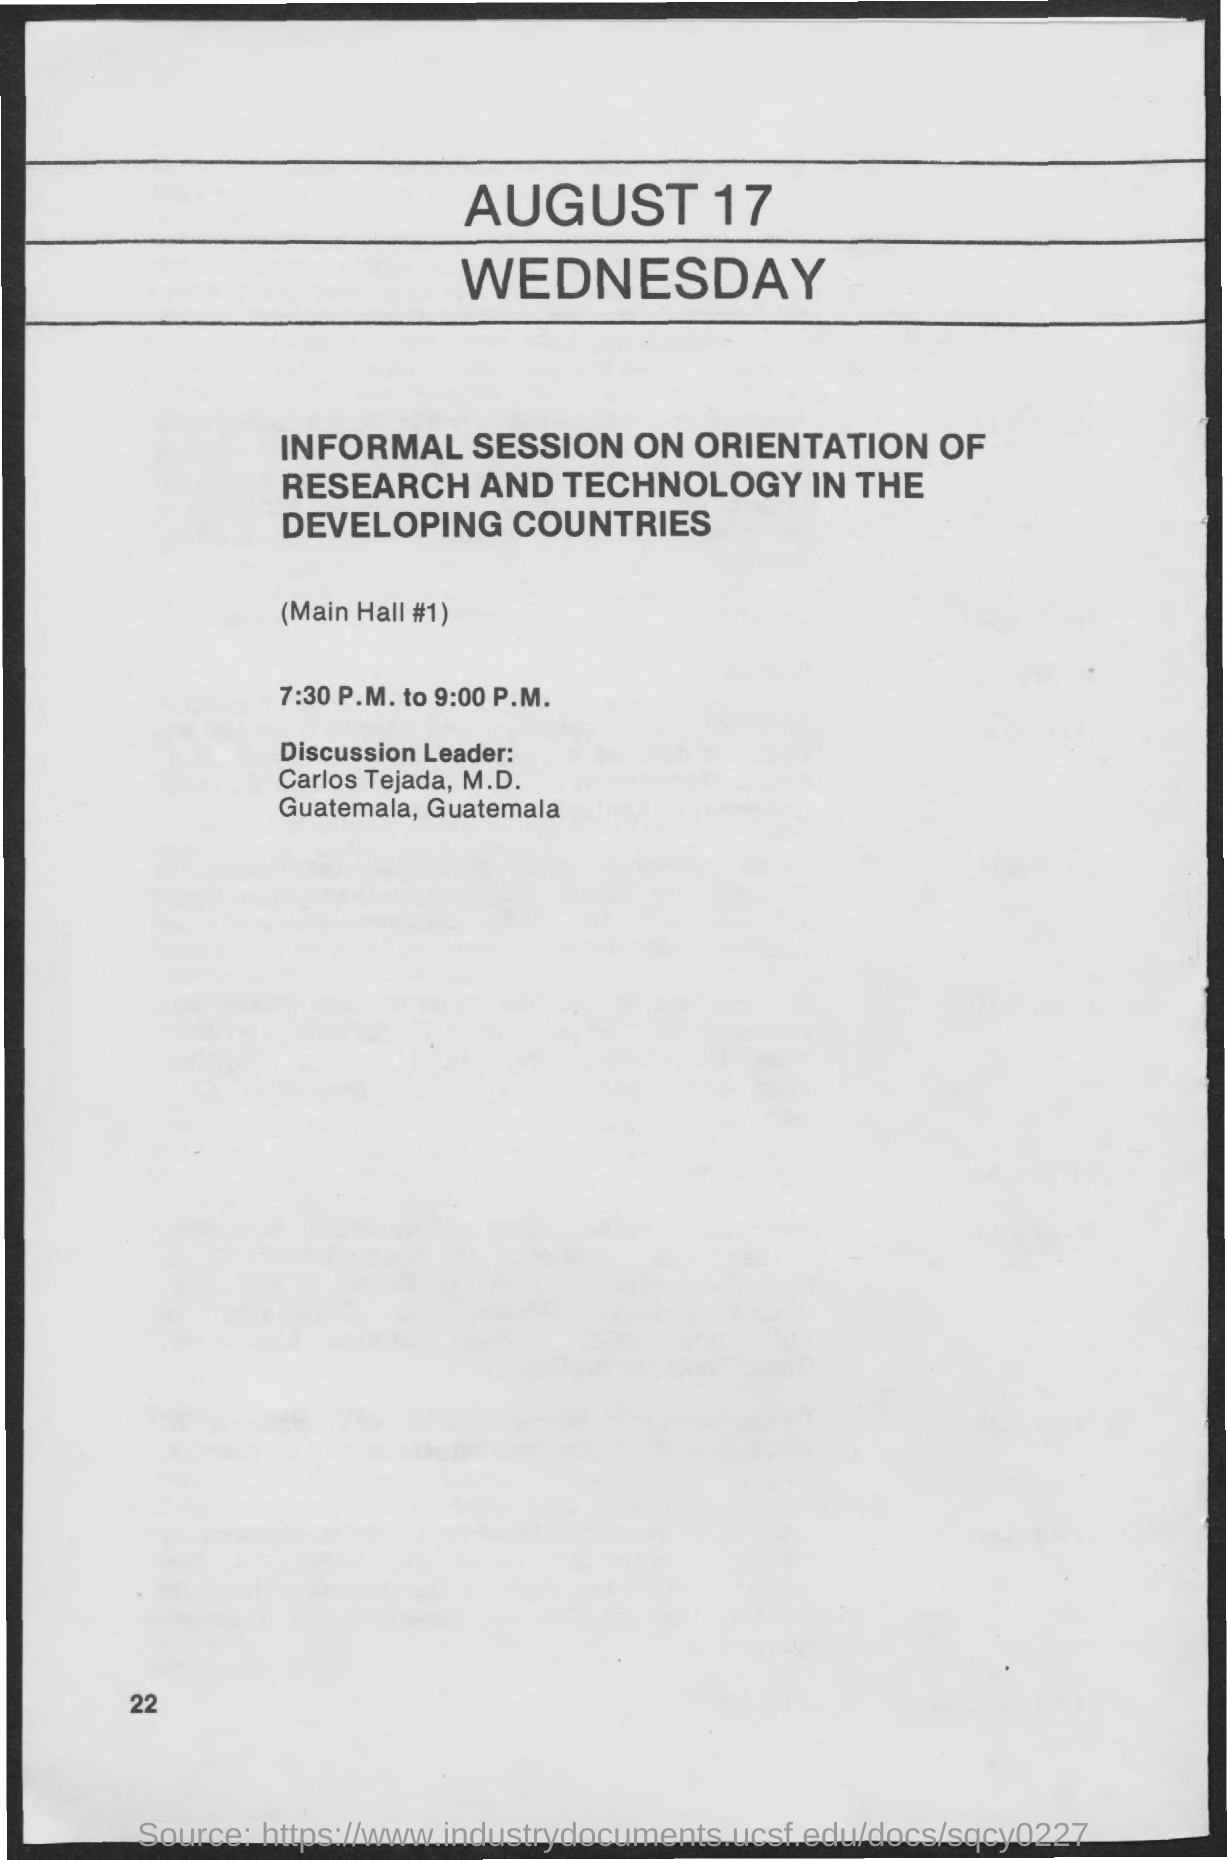Mention a couple of crucial points in this snapshot. The date on the document is August 17th. The informal session will take place from 7:30 P.M. to 9:00 P.M. 